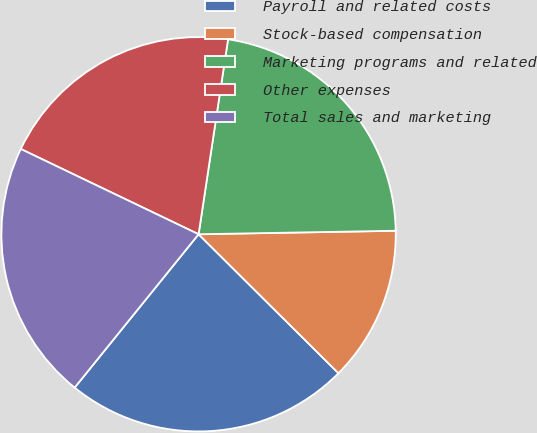<chart> <loc_0><loc_0><loc_500><loc_500><pie_chart><fcel>Payroll and related costs<fcel>Stock-based compensation<fcel>Marketing programs and related<fcel>Other expenses<fcel>Total sales and marketing<nl><fcel>23.37%<fcel>12.73%<fcel>22.33%<fcel>20.27%<fcel>21.3%<nl></chart> 